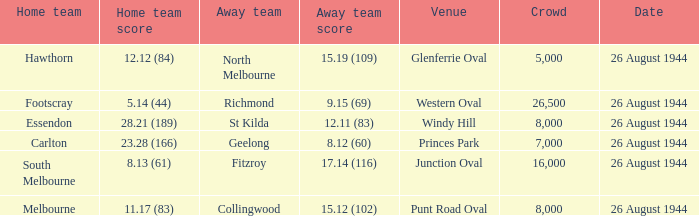What's the average crowd size when the Home team is melbourne? 8000.0. 